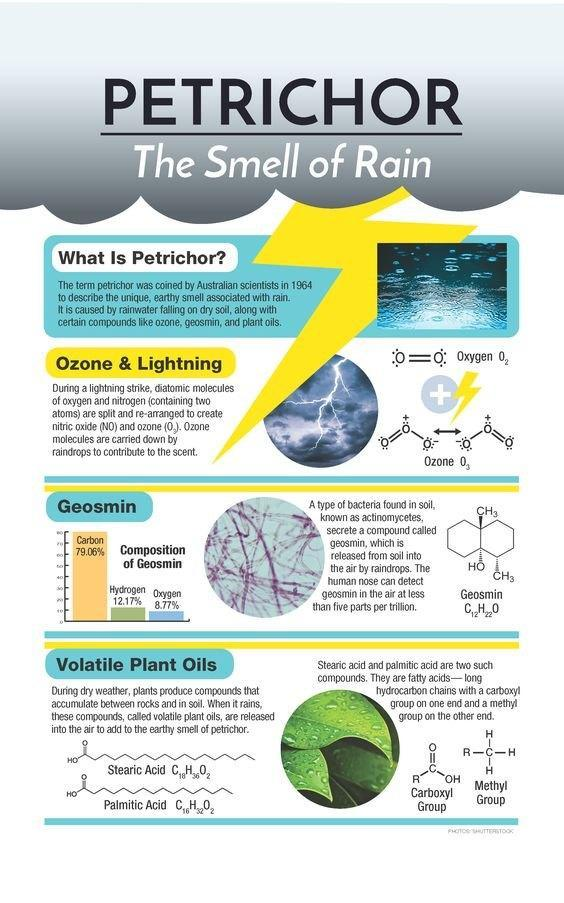What percentage of hydrogen and oxygen constitute Geosmin?
Answer the question with a short phrase. 20.94% What percentage of carbon and oxygen constitute Geosmin? 87.83% 